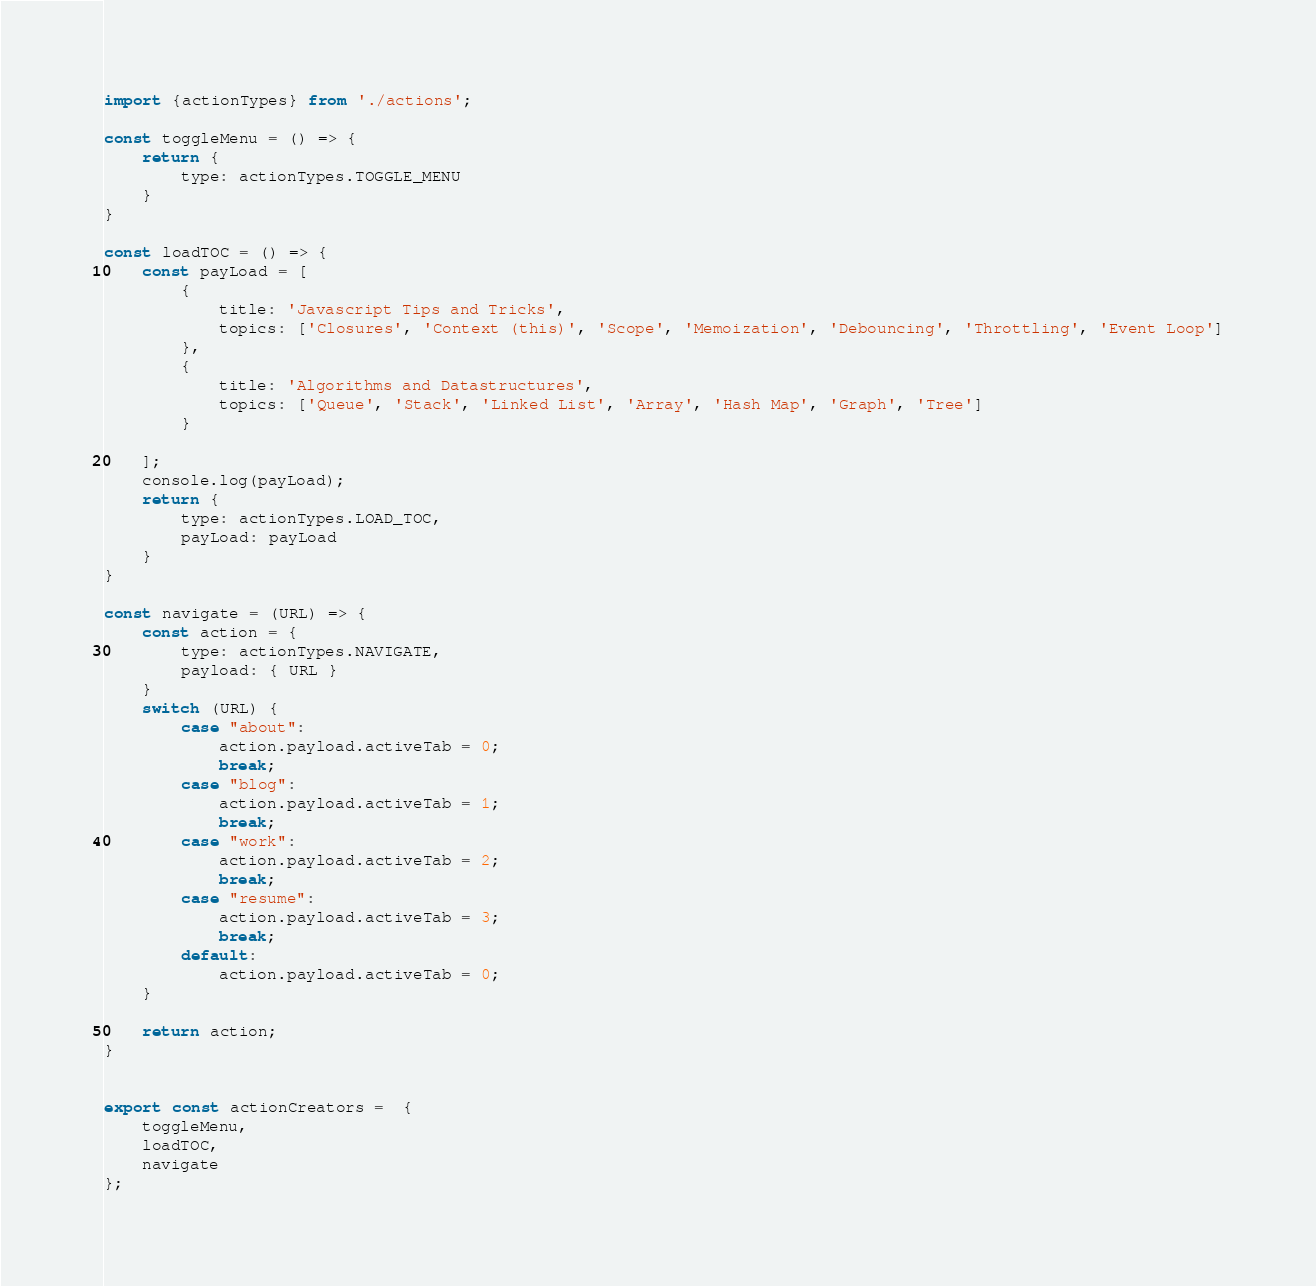<code> <loc_0><loc_0><loc_500><loc_500><_JavaScript_>import {actionTypes} from './actions';

const toggleMenu = () => {
    return {
        type: actionTypes.TOGGLE_MENU
    }
}

const loadTOC = () => {
    const payLoad = [
        {
            title: 'Javascript Tips and Tricks',
            topics: ['Closures', 'Context (this)', 'Scope', 'Memoization', 'Debouncing', 'Throttling', 'Event Loop']
        },
        {
            title: 'Algorithms and Datastructures',
            topics: ['Queue', 'Stack', 'Linked List', 'Array', 'Hash Map', 'Graph', 'Tree']
        }

    ];
    console.log(payLoad);
    return {
        type: actionTypes.LOAD_TOC,
        payLoad: payLoad
    }
}

const navigate = (URL) => {
    const action = {
        type: actionTypes.NAVIGATE,
        payload: { URL }
    }
    switch (URL) {
        case "about":
            action.payload.activeTab = 0;
            break;
        case "blog":
            action.payload.activeTab = 1;
            break;
        case "work":
            action.payload.activeTab = 2;
            break;            
        case "resume":
            action.payload.activeTab = 3;
            break;
        default:
            action.payload.activeTab = 0;
    }

    return action;
}


export const actionCreators =  {
    toggleMenu,
    loadTOC,
    navigate
};</code> 